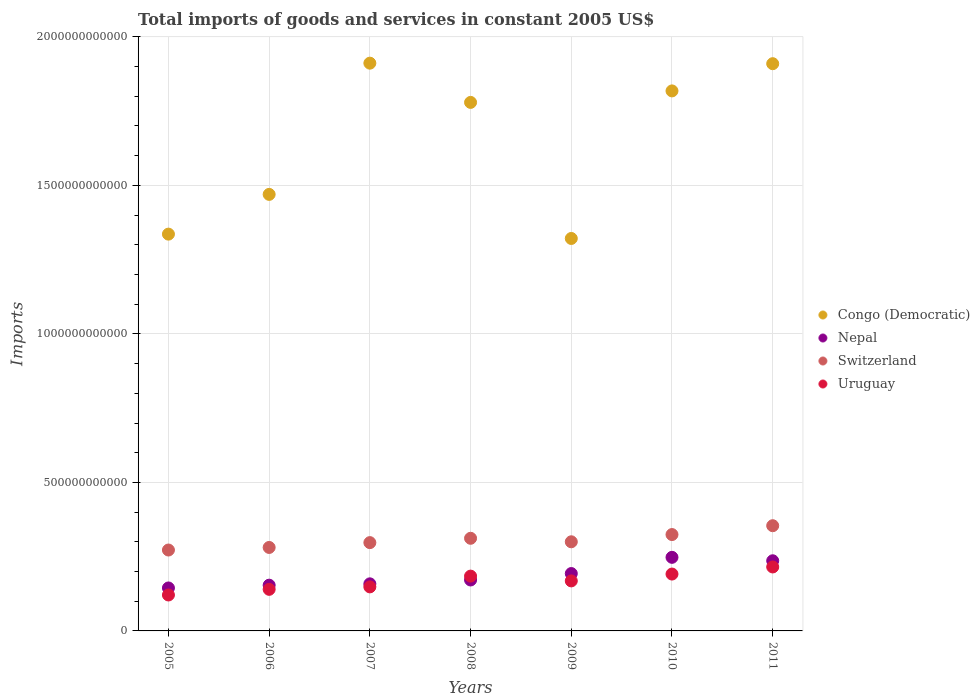How many different coloured dotlines are there?
Your answer should be very brief. 4. Is the number of dotlines equal to the number of legend labels?
Your answer should be compact. Yes. What is the total imports of goods and services in Switzerland in 2008?
Keep it short and to the point. 3.12e+11. Across all years, what is the maximum total imports of goods and services in Nepal?
Offer a terse response. 2.48e+11. Across all years, what is the minimum total imports of goods and services in Uruguay?
Give a very brief answer. 1.21e+11. In which year was the total imports of goods and services in Switzerland maximum?
Keep it short and to the point. 2011. In which year was the total imports of goods and services in Nepal minimum?
Offer a terse response. 2005. What is the total total imports of goods and services in Congo (Democratic) in the graph?
Give a very brief answer. 1.15e+13. What is the difference between the total imports of goods and services in Nepal in 2008 and that in 2010?
Your answer should be compact. -7.63e+1. What is the difference between the total imports of goods and services in Uruguay in 2011 and the total imports of goods and services in Switzerland in 2007?
Provide a short and direct response. -8.20e+1. What is the average total imports of goods and services in Uruguay per year?
Offer a very short reply. 1.67e+11. In the year 2011, what is the difference between the total imports of goods and services in Congo (Democratic) and total imports of goods and services in Uruguay?
Your response must be concise. 1.69e+12. What is the ratio of the total imports of goods and services in Nepal in 2010 to that in 2011?
Ensure brevity in your answer.  1.05. What is the difference between the highest and the second highest total imports of goods and services in Switzerland?
Offer a terse response. 2.98e+1. What is the difference between the highest and the lowest total imports of goods and services in Uruguay?
Your response must be concise. 9.43e+1. In how many years, is the total imports of goods and services in Uruguay greater than the average total imports of goods and services in Uruguay taken over all years?
Ensure brevity in your answer.  4. Is the sum of the total imports of goods and services in Congo (Democratic) in 2008 and 2011 greater than the maximum total imports of goods and services in Switzerland across all years?
Ensure brevity in your answer.  Yes. Is it the case that in every year, the sum of the total imports of goods and services in Switzerland and total imports of goods and services in Uruguay  is greater than the sum of total imports of goods and services in Nepal and total imports of goods and services in Congo (Democratic)?
Offer a very short reply. Yes. Is the total imports of goods and services in Congo (Democratic) strictly greater than the total imports of goods and services in Uruguay over the years?
Keep it short and to the point. Yes. Is the total imports of goods and services in Uruguay strictly less than the total imports of goods and services in Congo (Democratic) over the years?
Keep it short and to the point. Yes. How many dotlines are there?
Provide a succinct answer. 4. What is the difference between two consecutive major ticks on the Y-axis?
Ensure brevity in your answer.  5.00e+11. Are the values on the major ticks of Y-axis written in scientific E-notation?
Make the answer very short. No. Does the graph contain any zero values?
Your answer should be compact. No. How many legend labels are there?
Your answer should be compact. 4. What is the title of the graph?
Make the answer very short. Total imports of goods and services in constant 2005 US$. Does "Togo" appear as one of the legend labels in the graph?
Provide a succinct answer. No. What is the label or title of the X-axis?
Keep it short and to the point. Years. What is the label or title of the Y-axis?
Give a very brief answer. Imports. What is the Imports of Congo (Democratic) in 2005?
Offer a very short reply. 1.34e+12. What is the Imports in Nepal in 2005?
Offer a terse response. 1.45e+11. What is the Imports of Switzerland in 2005?
Your answer should be very brief. 2.72e+11. What is the Imports in Uruguay in 2005?
Keep it short and to the point. 1.21e+11. What is the Imports in Congo (Democratic) in 2006?
Offer a terse response. 1.47e+12. What is the Imports of Nepal in 2006?
Ensure brevity in your answer.  1.54e+11. What is the Imports in Switzerland in 2006?
Keep it short and to the point. 2.81e+11. What is the Imports in Uruguay in 2006?
Your answer should be very brief. 1.40e+11. What is the Imports in Congo (Democratic) in 2007?
Provide a succinct answer. 1.91e+12. What is the Imports of Nepal in 2007?
Your response must be concise. 1.59e+11. What is the Imports in Switzerland in 2007?
Offer a terse response. 2.97e+11. What is the Imports of Uruguay in 2007?
Your answer should be very brief. 1.48e+11. What is the Imports of Congo (Democratic) in 2008?
Ensure brevity in your answer.  1.78e+12. What is the Imports of Nepal in 2008?
Make the answer very short. 1.72e+11. What is the Imports in Switzerland in 2008?
Provide a succinct answer. 3.12e+11. What is the Imports in Uruguay in 2008?
Provide a short and direct response. 1.85e+11. What is the Imports of Congo (Democratic) in 2009?
Offer a very short reply. 1.32e+12. What is the Imports in Nepal in 2009?
Offer a very short reply. 1.93e+11. What is the Imports of Switzerland in 2009?
Keep it short and to the point. 3.00e+11. What is the Imports in Uruguay in 2009?
Offer a very short reply. 1.68e+11. What is the Imports in Congo (Democratic) in 2010?
Offer a very short reply. 1.82e+12. What is the Imports of Nepal in 2010?
Your answer should be compact. 2.48e+11. What is the Imports of Switzerland in 2010?
Offer a terse response. 3.24e+11. What is the Imports of Uruguay in 2010?
Offer a terse response. 1.91e+11. What is the Imports of Congo (Democratic) in 2011?
Offer a very short reply. 1.91e+12. What is the Imports of Nepal in 2011?
Keep it short and to the point. 2.36e+11. What is the Imports in Switzerland in 2011?
Your answer should be very brief. 3.54e+11. What is the Imports of Uruguay in 2011?
Make the answer very short. 2.15e+11. Across all years, what is the maximum Imports in Congo (Democratic)?
Ensure brevity in your answer.  1.91e+12. Across all years, what is the maximum Imports of Nepal?
Your answer should be very brief. 2.48e+11. Across all years, what is the maximum Imports in Switzerland?
Offer a very short reply. 3.54e+11. Across all years, what is the maximum Imports in Uruguay?
Offer a very short reply. 2.15e+11. Across all years, what is the minimum Imports in Congo (Democratic)?
Offer a very short reply. 1.32e+12. Across all years, what is the minimum Imports in Nepal?
Your response must be concise. 1.45e+11. Across all years, what is the minimum Imports of Switzerland?
Offer a terse response. 2.72e+11. Across all years, what is the minimum Imports of Uruguay?
Keep it short and to the point. 1.21e+11. What is the total Imports of Congo (Democratic) in the graph?
Make the answer very short. 1.15e+13. What is the total Imports in Nepal in the graph?
Offer a very short reply. 1.31e+12. What is the total Imports of Switzerland in the graph?
Ensure brevity in your answer.  2.14e+12. What is the total Imports in Uruguay in the graph?
Ensure brevity in your answer.  1.17e+12. What is the difference between the Imports of Congo (Democratic) in 2005 and that in 2006?
Ensure brevity in your answer.  -1.34e+11. What is the difference between the Imports in Nepal in 2005 and that in 2006?
Your answer should be compact. -9.34e+09. What is the difference between the Imports of Switzerland in 2005 and that in 2006?
Your answer should be very brief. -8.65e+09. What is the difference between the Imports of Uruguay in 2005 and that in 2006?
Provide a short and direct response. -1.90e+1. What is the difference between the Imports in Congo (Democratic) in 2005 and that in 2007?
Offer a terse response. -5.76e+11. What is the difference between the Imports in Nepal in 2005 and that in 2007?
Provide a short and direct response. -1.39e+1. What is the difference between the Imports of Switzerland in 2005 and that in 2007?
Ensure brevity in your answer.  -2.49e+1. What is the difference between the Imports of Uruguay in 2005 and that in 2007?
Provide a succinct answer. -2.73e+1. What is the difference between the Imports in Congo (Democratic) in 2005 and that in 2008?
Keep it short and to the point. -4.44e+11. What is the difference between the Imports in Nepal in 2005 and that in 2008?
Offer a terse response. -2.69e+1. What is the difference between the Imports in Switzerland in 2005 and that in 2008?
Your response must be concise. -3.95e+1. What is the difference between the Imports of Uruguay in 2005 and that in 2008?
Provide a short and direct response. -6.35e+1. What is the difference between the Imports of Congo (Democratic) in 2005 and that in 2009?
Offer a very short reply. 1.46e+1. What is the difference between the Imports in Nepal in 2005 and that in 2009?
Provide a short and direct response. -4.85e+1. What is the difference between the Imports in Switzerland in 2005 and that in 2009?
Give a very brief answer. -2.77e+1. What is the difference between the Imports of Uruguay in 2005 and that in 2009?
Make the answer very short. -4.74e+1. What is the difference between the Imports of Congo (Democratic) in 2005 and that in 2010?
Provide a short and direct response. -4.82e+11. What is the difference between the Imports of Nepal in 2005 and that in 2010?
Offer a terse response. -1.03e+11. What is the difference between the Imports of Switzerland in 2005 and that in 2010?
Offer a terse response. -5.21e+1. What is the difference between the Imports in Uruguay in 2005 and that in 2010?
Your response must be concise. -7.04e+1. What is the difference between the Imports of Congo (Democratic) in 2005 and that in 2011?
Provide a short and direct response. -5.74e+11. What is the difference between the Imports of Nepal in 2005 and that in 2011?
Keep it short and to the point. -9.15e+1. What is the difference between the Imports of Switzerland in 2005 and that in 2011?
Your answer should be compact. -8.19e+1. What is the difference between the Imports of Uruguay in 2005 and that in 2011?
Offer a terse response. -9.43e+1. What is the difference between the Imports of Congo (Democratic) in 2006 and that in 2007?
Give a very brief answer. -4.42e+11. What is the difference between the Imports of Nepal in 2006 and that in 2007?
Your answer should be compact. -4.54e+09. What is the difference between the Imports in Switzerland in 2006 and that in 2007?
Make the answer very short. -1.63e+1. What is the difference between the Imports of Uruguay in 2006 and that in 2007?
Your answer should be compact. -8.29e+09. What is the difference between the Imports of Congo (Democratic) in 2006 and that in 2008?
Offer a terse response. -3.10e+11. What is the difference between the Imports in Nepal in 2006 and that in 2008?
Keep it short and to the point. -1.75e+1. What is the difference between the Imports in Switzerland in 2006 and that in 2008?
Make the answer very short. -3.09e+1. What is the difference between the Imports in Uruguay in 2006 and that in 2008?
Make the answer very short. -4.45e+1. What is the difference between the Imports of Congo (Democratic) in 2006 and that in 2009?
Make the answer very short. 1.48e+11. What is the difference between the Imports in Nepal in 2006 and that in 2009?
Keep it short and to the point. -3.92e+1. What is the difference between the Imports in Switzerland in 2006 and that in 2009?
Make the answer very short. -1.91e+1. What is the difference between the Imports in Uruguay in 2006 and that in 2009?
Offer a terse response. -2.84e+1. What is the difference between the Imports of Congo (Democratic) in 2006 and that in 2010?
Your answer should be very brief. -3.48e+11. What is the difference between the Imports in Nepal in 2006 and that in 2010?
Your response must be concise. -9.38e+1. What is the difference between the Imports in Switzerland in 2006 and that in 2010?
Provide a succinct answer. -4.34e+1. What is the difference between the Imports of Uruguay in 2006 and that in 2010?
Give a very brief answer. -5.15e+1. What is the difference between the Imports in Congo (Democratic) in 2006 and that in 2011?
Provide a short and direct response. -4.40e+11. What is the difference between the Imports in Nepal in 2006 and that in 2011?
Offer a very short reply. -8.22e+1. What is the difference between the Imports in Switzerland in 2006 and that in 2011?
Provide a succinct answer. -7.32e+1. What is the difference between the Imports in Uruguay in 2006 and that in 2011?
Ensure brevity in your answer.  -7.53e+1. What is the difference between the Imports of Congo (Democratic) in 2007 and that in 2008?
Offer a terse response. 1.32e+11. What is the difference between the Imports of Nepal in 2007 and that in 2008?
Your answer should be very brief. -1.30e+1. What is the difference between the Imports of Switzerland in 2007 and that in 2008?
Your answer should be compact. -1.46e+1. What is the difference between the Imports in Uruguay in 2007 and that in 2008?
Your answer should be compact. -3.62e+1. What is the difference between the Imports in Congo (Democratic) in 2007 and that in 2009?
Your answer should be compact. 5.90e+11. What is the difference between the Imports in Nepal in 2007 and that in 2009?
Ensure brevity in your answer.  -3.47e+1. What is the difference between the Imports in Switzerland in 2007 and that in 2009?
Ensure brevity in your answer.  -2.79e+09. What is the difference between the Imports in Uruguay in 2007 and that in 2009?
Give a very brief answer. -2.01e+1. What is the difference between the Imports of Congo (Democratic) in 2007 and that in 2010?
Ensure brevity in your answer.  9.34e+1. What is the difference between the Imports of Nepal in 2007 and that in 2010?
Offer a terse response. -8.92e+1. What is the difference between the Imports of Switzerland in 2007 and that in 2010?
Give a very brief answer. -2.71e+1. What is the difference between the Imports in Uruguay in 2007 and that in 2010?
Give a very brief answer. -4.32e+1. What is the difference between the Imports of Congo (Democratic) in 2007 and that in 2011?
Your answer should be very brief. 1.77e+09. What is the difference between the Imports of Nepal in 2007 and that in 2011?
Offer a terse response. -7.76e+1. What is the difference between the Imports of Switzerland in 2007 and that in 2011?
Your response must be concise. -5.69e+1. What is the difference between the Imports of Uruguay in 2007 and that in 2011?
Provide a succinct answer. -6.70e+1. What is the difference between the Imports in Congo (Democratic) in 2008 and that in 2009?
Your answer should be very brief. 4.58e+11. What is the difference between the Imports of Nepal in 2008 and that in 2009?
Offer a very short reply. -2.17e+1. What is the difference between the Imports of Switzerland in 2008 and that in 2009?
Give a very brief answer. 1.18e+1. What is the difference between the Imports in Uruguay in 2008 and that in 2009?
Offer a very short reply. 1.61e+1. What is the difference between the Imports of Congo (Democratic) in 2008 and that in 2010?
Your answer should be compact. -3.87e+1. What is the difference between the Imports in Nepal in 2008 and that in 2010?
Make the answer very short. -7.63e+1. What is the difference between the Imports in Switzerland in 2008 and that in 2010?
Offer a very short reply. -1.25e+1. What is the difference between the Imports of Uruguay in 2008 and that in 2010?
Offer a very short reply. -6.94e+09. What is the difference between the Imports in Congo (Democratic) in 2008 and that in 2011?
Give a very brief answer. -1.30e+11. What is the difference between the Imports in Nepal in 2008 and that in 2011?
Provide a succinct answer. -6.46e+1. What is the difference between the Imports of Switzerland in 2008 and that in 2011?
Make the answer very short. -4.23e+1. What is the difference between the Imports in Uruguay in 2008 and that in 2011?
Keep it short and to the point. -3.08e+1. What is the difference between the Imports in Congo (Democratic) in 2009 and that in 2010?
Give a very brief answer. -4.97e+11. What is the difference between the Imports in Nepal in 2009 and that in 2010?
Your answer should be compact. -5.46e+1. What is the difference between the Imports in Switzerland in 2009 and that in 2010?
Give a very brief answer. -2.43e+1. What is the difference between the Imports in Uruguay in 2009 and that in 2010?
Provide a succinct answer. -2.30e+1. What is the difference between the Imports in Congo (Democratic) in 2009 and that in 2011?
Provide a short and direct response. -5.88e+11. What is the difference between the Imports in Nepal in 2009 and that in 2011?
Provide a short and direct response. -4.30e+1. What is the difference between the Imports in Switzerland in 2009 and that in 2011?
Your answer should be compact. -5.41e+1. What is the difference between the Imports of Uruguay in 2009 and that in 2011?
Provide a succinct answer. -4.69e+1. What is the difference between the Imports in Congo (Democratic) in 2010 and that in 2011?
Your answer should be compact. -9.16e+1. What is the difference between the Imports in Nepal in 2010 and that in 2011?
Offer a terse response. 1.16e+1. What is the difference between the Imports in Switzerland in 2010 and that in 2011?
Your answer should be compact. -2.98e+1. What is the difference between the Imports in Uruguay in 2010 and that in 2011?
Offer a terse response. -2.39e+1. What is the difference between the Imports of Congo (Democratic) in 2005 and the Imports of Nepal in 2006?
Your answer should be very brief. 1.18e+12. What is the difference between the Imports of Congo (Democratic) in 2005 and the Imports of Switzerland in 2006?
Your response must be concise. 1.05e+12. What is the difference between the Imports in Congo (Democratic) in 2005 and the Imports in Uruguay in 2006?
Make the answer very short. 1.20e+12. What is the difference between the Imports in Nepal in 2005 and the Imports in Switzerland in 2006?
Provide a succinct answer. -1.36e+11. What is the difference between the Imports of Nepal in 2005 and the Imports of Uruguay in 2006?
Offer a terse response. 4.66e+09. What is the difference between the Imports in Switzerland in 2005 and the Imports in Uruguay in 2006?
Offer a terse response. 1.32e+11. What is the difference between the Imports in Congo (Democratic) in 2005 and the Imports in Nepal in 2007?
Keep it short and to the point. 1.18e+12. What is the difference between the Imports in Congo (Democratic) in 2005 and the Imports in Switzerland in 2007?
Ensure brevity in your answer.  1.04e+12. What is the difference between the Imports of Congo (Democratic) in 2005 and the Imports of Uruguay in 2007?
Offer a terse response. 1.19e+12. What is the difference between the Imports in Nepal in 2005 and the Imports in Switzerland in 2007?
Provide a succinct answer. -1.53e+11. What is the difference between the Imports of Nepal in 2005 and the Imports of Uruguay in 2007?
Make the answer very short. -3.63e+09. What is the difference between the Imports of Switzerland in 2005 and the Imports of Uruguay in 2007?
Keep it short and to the point. 1.24e+11. What is the difference between the Imports in Congo (Democratic) in 2005 and the Imports in Nepal in 2008?
Provide a short and direct response. 1.16e+12. What is the difference between the Imports of Congo (Democratic) in 2005 and the Imports of Switzerland in 2008?
Keep it short and to the point. 1.02e+12. What is the difference between the Imports of Congo (Democratic) in 2005 and the Imports of Uruguay in 2008?
Provide a short and direct response. 1.15e+12. What is the difference between the Imports of Nepal in 2005 and the Imports of Switzerland in 2008?
Give a very brief answer. -1.67e+11. What is the difference between the Imports of Nepal in 2005 and the Imports of Uruguay in 2008?
Your answer should be compact. -3.99e+1. What is the difference between the Imports in Switzerland in 2005 and the Imports in Uruguay in 2008?
Ensure brevity in your answer.  8.79e+1. What is the difference between the Imports of Congo (Democratic) in 2005 and the Imports of Nepal in 2009?
Make the answer very short. 1.14e+12. What is the difference between the Imports in Congo (Democratic) in 2005 and the Imports in Switzerland in 2009?
Your answer should be compact. 1.04e+12. What is the difference between the Imports in Congo (Democratic) in 2005 and the Imports in Uruguay in 2009?
Offer a very short reply. 1.17e+12. What is the difference between the Imports of Nepal in 2005 and the Imports of Switzerland in 2009?
Your answer should be very brief. -1.55e+11. What is the difference between the Imports of Nepal in 2005 and the Imports of Uruguay in 2009?
Ensure brevity in your answer.  -2.38e+1. What is the difference between the Imports of Switzerland in 2005 and the Imports of Uruguay in 2009?
Offer a terse response. 1.04e+11. What is the difference between the Imports in Congo (Democratic) in 2005 and the Imports in Nepal in 2010?
Your response must be concise. 1.09e+12. What is the difference between the Imports of Congo (Democratic) in 2005 and the Imports of Switzerland in 2010?
Offer a terse response. 1.01e+12. What is the difference between the Imports of Congo (Democratic) in 2005 and the Imports of Uruguay in 2010?
Provide a succinct answer. 1.14e+12. What is the difference between the Imports of Nepal in 2005 and the Imports of Switzerland in 2010?
Ensure brevity in your answer.  -1.80e+11. What is the difference between the Imports in Nepal in 2005 and the Imports in Uruguay in 2010?
Provide a short and direct response. -4.68e+1. What is the difference between the Imports of Switzerland in 2005 and the Imports of Uruguay in 2010?
Ensure brevity in your answer.  8.09e+1. What is the difference between the Imports in Congo (Democratic) in 2005 and the Imports in Nepal in 2011?
Keep it short and to the point. 1.10e+12. What is the difference between the Imports of Congo (Democratic) in 2005 and the Imports of Switzerland in 2011?
Give a very brief answer. 9.82e+11. What is the difference between the Imports of Congo (Democratic) in 2005 and the Imports of Uruguay in 2011?
Provide a short and direct response. 1.12e+12. What is the difference between the Imports in Nepal in 2005 and the Imports in Switzerland in 2011?
Provide a succinct answer. -2.10e+11. What is the difference between the Imports in Nepal in 2005 and the Imports in Uruguay in 2011?
Give a very brief answer. -7.07e+1. What is the difference between the Imports of Switzerland in 2005 and the Imports of Uruguay in 2011?
Ensure brevity in your answer.  5.70e+1. What is the difference between the Imports in Congo (Democratic) in 2006 and the Imports in Nepal in 2007?
Your response must be concise. 1.31e+12. What is the difference between the Imports of Congo (Democratic) in 2006 and the Imports of Switzerland in 2007?
Give a very brief answer. 1.17e+12. What is the difference between the Imports of Congo (Democratic) in 2006 and the Imports of Uruguay in 2007?
Offer a terse response. 1.32e+12. What is the difference between the Imports in Nepal in 2006 and the Imports in Switzerland in 2007?
Ensure brevity in your answer.  -1.43e+11. What is the difference between the Imports of Nepal in 2006 and the Imports of Uruguay in 2007?
Make the answer very short. 5.71e+09. What is the difference between the Imports in Switzerland in 2006 and the Imports in Uruguay in 2007?
Your answer should be compact. 1.33e+11. What is the difference between the Imports of Congo (Democratic) in 2006 and the Imports of Nepal in 2008?
Ensure brevity in your answer.  1.30e+12. What is the difference between the Imports in Congo (Democratic) in 2006 and the Imports in Switzerland in 2008?
Your answer should be compact. 1.16e+12. What is the difference between the Imports in Congo (Democratic) in 2006 and the Imports in Uruguay in 2008?
Provide a succinct answer. 1.29e+12. What is the difference between the Imports of Nepal in 2006 and the Imports of Switzerland in 2008?
Make the answer very short. -1.58e+11. What is the difference between the Imports in Nepal in 2006 and the Imports in Uruguay in 2008?
Offer a terse response. -3.05e+1. What is the difference between the Imports of Switzerland in 2006 and the Imports of Uruguay in 2008?
Your answer should be compact. 9.65e+1. What is the difference between the Imports in Congo (Democratic) in 2006 and the Imports in Nepal in 2009?
Make the answer very short. 1.28e+12. What is the difference between the Imports in Congo (Democratic) in 2006 and the Imports in Switzerland in 2009?
Provide a short and direct response. 1.17e+12. What is the difference between the Imports of Congo (Democratic) in 2006 and the Imports of Uruguay in 2009?
Offer a very short reply. 1.30e+12. What is the difference between the Imports in Nepal in 2006 and the Imports in Switzerland in 2009?
Offer a very short reply. -1.46e+11. What is the difference between the Imports of Nepal in 2006 and the Imports of Uruguay in 2009?
Offer a very short reply. -1.44e+1. What is the difference between the Imports in Switzerland in 2006 and the Imports in Uruguay in 2009?
Your answer should be compact. 1.13e+11. What is the difference between the Imports of Congo (Democratic) in 2006 and the Imports of Nepal in 2010?
Keep it short and to the point. 1.22e+12. What is the difference between the Imports of Congo (Democratic) in 2006 and the Imports of Switzerland in 2010?
Your answer should be compact. 1.15e+12. What is the difference between the Imports of Congo (Democratic) in 2006 and the Imports of Uruguay in 2010?
Provide a succinct answer. 1.28e+12. What is the difference between the Imports of Nepal in 2006 and the Imports of Switzerland in 2010?
Provide a short and direct response. -1.70e+11. What is the difference between the Imports of Nepal in 2006 and the Imports of Uruguay in 2010?
Offer a very short reply. -3.75e+1. What is the difference between the Imports of Switzerland in 2006 and the Imports of Uruguay in 2010?
Make the answer very short. 8.96e+1. What is the difference between the Imports of Congo (Democratic) in 2006 and the Imports of Nepal in 2011?
Offer a very short reply. 1.23e+12. What is the difference between the Imports in Congo (Democratic) in 2006 and the Imports in Switzerland in 2011?
Make the answer very short. 1.12e+12. What is the difference between the Imports of Congo (Democratic) in 2006 and the Imports of Uruguay in 2011?
Provide a short and direct response. 1.25e+12. What is the difference between the Imports in Nepal in 2006 and the Imports in Switzerland in 2011?
Ensure brevity in your answer.  -2.00e+11. What is the difference between the Imports in Nepal in 2006 and the Imports in Uruguay in 2011?
Give a very brief answer. -6.13e+1. What is the difference between the Imports of Switzerland in 2006 and the Imports of Uruguay in 2011?
Offer a terse response. 6.57e+1. What is the difference between the Imports in Congo (Democratic) in 2007 and the Imports in Nepal in 2008?
Offer a terse response. 1.74e+12. What is the difference between the Imports in Congo (Democratic) in 2007 and the Imports in Switzerland in 2008?
Provide a succinct answer. 1.60e+12. What is the difference between the Imports in Congo (Democratic) in 2007 and the Imports in Uruguay in 2008?
Provide a short and direct response. 1.73e+12. What is the difference between the Imports of Nepal in 2007 and the Imports of Switzerland in 2008?
Your answer should be very brief. -1.53e+11. What is the difference between the Imports of Nepal in 2007 and the Imports of Uruguay in 2008?
Your answer should be very brief. -2.60e+1. What is the difference between the Imports of Switzerland in 2007 and the Imports of Uruguay in 2008?
Keep it short and to the point. 1.13e+11. What is the difference between the Imports in Congo (Democratic) in 2007 and the Imports in Nepal in 2009?
Ensure brevity in your answer.  1.72e+12. What is the difference between the Imports in Congo (Democratic) in 2007 and the Imports in Switzerland in 2009?
Keep it short and to the point. 1.61e+12. What is the difference between the Imports in Congo (Democratic) in 2007 and the Imports in Uruguay in 2009?
Provide a succinct answer. 1.74e+12. What is the difference between the Imports of Nepal in 2007 and the Imports of Switzerland in 2009?
Give a very brief answer. -1.42e+11. What is the difference between the Imports of Nepal in 2007 and the Imports of Uruguay in 2009?
Give a very brief answer. -9.88e+09. What is the difference between the Imports of Switzerland in 2007 and the Imports of Uruguay in 2009?
Ensure brevity in your answer.  1.29e+11. What is the difference between the Imports of Congo (Democratic) in 2007 and the Imports of Nepal in 2010?
Your answer should be very brief. 1.66e+12. What is the difference between the Imports in Congo (Democratic) in 2007 and the Imports in Switzerland in 2010?
Keep it short and to the point. 1.59e+12. What is the difference between the Imports in Congo (Democratic) in 2007 and the Imports in Uruguay in 2010?
Your response must be concise. 1.72e+12. What is the difference between the Imports in Nepal in 2007 and the Imports in Switzerland in 2010?
Your answer should be compact. -1.66e+11. What is the difference between the Imports of Nepal in 2007 and the Imports of Uruguay in 2010?
Your answer should be very brief. -3.29e+1. What is the difference between the Imports of Switzerland in 2007 and the Imports of Uruguay in 2010?
Offer a terse response. 1.06e+11. What is the difference between the Imports of Congo (Democratic) in 2007 and the Imports of Nepal in 2011?
Provide a short and direct response. 1.68e+12. What is the difference between the Imports of Congo (Democratic) in 2007 and the Imports of Switzerland in 2011?
Provide a succinct answer. 1.56e+12. What is the difference between the Imports in Congo (Democratic) in 2007 and the Imports in Uruguay in 2011?
Your answer should be compact. 1.70e+12. What is the difference between the Imports of Nepal in 2007 and the Imports of Switzerland in 2011?
Keep it short and to the point. -1.96e+11. What is the difference between the Imports of Nepal in 2007 and the Imports of Uruguay in 2011?
Make the answer very short. -5.68e+1. What is the difference between the Imports of Switzerland in 2007 and the Imports of Uruguay in 2011?
Your response must be concise. 8.20e+1. What is the difference between the Imports of Congo (Democratic) in 2008 and the Imports of Nepal in 2009?
Provide a succinct answer. 1.59e+12. What is the difference between the Imports in Congo (Democratic) in 2008 and the Imports in Switzerland in 2009?
Offer a terse response. 1.48e+12. What is the difference between the Imports in Congo (Democratic) in 2008 and the Imports in Uruguay in 2009?
Ensure brevity in your answer.  1.61e+12. What is the difference between the Imports in Nepal in 2008 and the Imports in Switzerland in 2009?
Your response must be concise. -1.29e+11. What is the difference between the Imports of Nepal in 2008 and the Imports of Uruguay in 2009?
Ensure brevity in your answer.  3.11e+09. What is the difference between the Imports of Switzerland in 2008 and the Imports of Uruguay in 2009?
Your answer should be compact. 1.43e+11. What is the difference between the Imports in Congo (Democratic) in 2008 and the Imports in Nepal in 2010?
Your response must be concise. 1.53e+12. What is the difference between the Imports in Congo (Democratic) in 2008 and the Imports in Switzerland in 2010?
Make the answer very short. 1.45e+12. What is the difference between the Imports of Congo (Democratic) in 2008 and the Imports of Uruguay in 2010?
Offer a very short reply. 1.59e+12. What is the difference between the Imports of Nepal in 2008 and the Imports of Switzerland in 2010?
Your answer should be very brief. -1.53e+11. What is the difference between the Imports of Nepal in 2008 and the Imports of Uruguay in 2010?
Your answer should be compact. -1.99e+1. What is the difference between the Imports of Switzerland in 2008 and the Imports of Uruguay in 2010?
Offer a very short reply. 1.20e+11. What is the difference between the Imports of Congo (Democratic) in 2008 and the Imports of Nepal in 2011?
Keep it short and to the point. 1.54e+12. What is the difference between the Imports of Congo (Democratic) in 2008 and the Imports of Switzerland in 2011?
Provide a short and direct response. 1.43e+12. What is the difference between the Imports in Congo (Democratic) in 2008 and the Imports in Uruguay in 2011?
Offer a very short reply. 1.56e+12. What is the difference between the Imports in Nepal in 2008 and the Imports in Switzerland in 2011?
Your answer should be very brief. -1.83e+11. What is the difference between the Imports in Nepal in 2008 and the Imports in Uruguay in 2011?
Make the answer very short. -4.38e+1. What is the difference between the Imports in Switzerland in 2008 and the Imports in Uruguay in 2011?
Make the answer very short. 9.66e+1. What is the difference between the Imports of Congo (Democratic) in 2009 and the Imports of Nepal in 2010?
Your answer should be very brief. 1.07e+12. What is the difference between the Imports of Congo (Democratic) in 2009 and the Imports of Switzerland in 2010?
Keep it short and to the point. 9.97e+11. What is the difference between the Imports in Congo (Democratic) in 2009 and the Imports in Uruguay in 2010?
Offer a very short reply. 1.13e+12. What is the difference between the Imports of Nepal in 2009 and the Imports of Switzerland in 2010?
Ensure brevity in your answer.  -1.31e+11. What is the difference between the Imports of Nepal in 2009 and the Imports of Uruguay in 2010?
Provide a succinct answer. 1.73e+09. What is the difference between the Imports of Switzerland in 2009 and the Imports of Uruguay in 2010?
Provide a succinct answer. 1.09e+11. What is the difference between the Imports in Congo (Democratic) in 2009 and the Imports in Nepal in 2011?
Offer a terse response. 1.09e+12. What is the difference between the Imports of Congo (Democratic) in 2009 and the Imports of Switzerland in 2011?
Offer a terse response. 9.67e+11. What is the difference between the Imports in Congo (Democratic) in 2009 and the Imports in Uruguay in 2011?
Your answer should be compact. 1.11e+12. What is the difference between the Imports of Nepal in 2009 and the Imports of Switzerland in 2011?
Ensure brevity in your answer.  -1.61e+11. What is the difference between the Imports of Nepal in 2009 and the Imports of Uruguay in 2011?
Your answer should be very brief. -2.21e+1. What is the difference between the Imports in Switzerland in 2009 and the Imports in Uruguay in 2011?
Provide a succinct answer. 8.48e+1. What is the difference between the Imports of Congo (Democratic) in 2010 and the Imports of Nepal in 2011?
Your answer should be compact. 1.58e+12. What is the difference between the Imports in Congo (Democratic) in 2010 and the Imports in Switzerland in 2011?
Offer a terse response. 1.46e+12. What is the difference between the Imports of Congo (Democratic) in 2010 and the Imports of Uruguay in 2011?
Your answer should be very brief. 1.60e+12. What is the difference between the Imports in Nepal in 2010 and the Imports in Switzerland in 2011?
Your answer should be compact. -1.06e+11. What is the difference between the Imports in Nepal in 2010 and the Imports in Uruguay in 2011?
Your answer should be very brief. 3.24e+1. What is the difference between the Imports in Switzerland in 2010 and the Imports in Uruguay in 2011?
Ensure brevity in your answer.  1.09e+11. What is the average Imports of Congo (Democratic) per year?
Provide a short and direct response. 1.65e+12. What is the average Imports in Nepal per year?
Keep it short and to the point. 1.87e+11. What is the average Imports in Switzerland per year?
Your answer should be very brief. 3.06e+11. What is the average Imports in Uruguay per year?
Your answer should be very brief. 1.67e+11. In the year 2005, what is the difference between the Imports of Congo (Democratic) and Imports of Nepal?
Give a very brief answer. 1.19e+12. In the year 2005, what is the difference between the Imports of Congo (Democratic) and Imports of Switzerland?
Provide a succinct answer. 1.06e+12. In the year 2005, what is the difference between the Imports of Congo (Democratic) and Imports of Uruguay?
Offer a terse response. 1.21e+12. In the year 2005, what is the difference between the Imports of Nepal and Imports of Switzerland?
Your answer should be compact. -1.28e+11. In the year 2005, what is the difference between the Imports of Nepal and Imports of Uruguay?
Provide a short and direct response. 2.36e+1. In the year 2005, what is the difference between the Imports of Switzerland and Imports of Uruguay?
Ensure brevity in your answer.  1.51e+11. In the year 2006, what is the difference between the Imports in Congo (Democratic) and Imports in Nepal?
Your response must be concise. 1.32e+12. In the year 2006, what is the difference between the Imports in Congo (Democratic) and Imports in Switzerland?
Offer a terse response. 1.19e+12. In the year 2006, what is the difference between the Imports of Congo (Democratic) and Imports of Uruguay?
Offer a terse response. 1.33e+12. In the year 2006, what is the difference between the Imports in Nepal and Imports in Switzerland?
Provide a short and direct response. -1.27e+11. In the year 2006, what is the difference between the Imports in Nepal and Imports in Uruguay?
Your answer should be very brief. 1.40e+1. In the year 2006, what is the difference between the Imports of Switzerland and Imports of Uruguay?
Give a very brief answer. 1.41e+11. In the year 2007, what is the difference between the Imports of Congo (Democratic) and Imports of Nepal?
Your answer should be compact. 1.75e+12. In the year 2007, what is the difference between the Imports in Congo (Democratic) and Imports in Switzerland?
Your response must be concise. 1.61e+12. In the year 2007, what is the difference between the Imports of Congo (Democratic) and Imports of Uruguay?
Make the answer very short. 1.76e+12. In the year 2007, what is the difference between the Imports of Nepal and Imports of Switzerland?
Make the answer very short. -1.39e+11. In the year 2007, what is the difference between the Imports in Nepal and Imports in Uruguay?
Offer a terse response. 1.02e+1. In the year 2007, what is the difference between the Imports of Switzerland and Imports of Uruguay?
Give a very brief answer. 1.49e+11. In the year 2008, what is the difference between the Imports of Congo (Democratic) and Imports of Nepal?
Offer a very short reply. 1.61e+12. In the year 2008, what is the difference between the Imports of Congo (Democratic) and Imports of Switzerland?
Provide a succinct answer. 1.47e+12. In the year 2008, what is the difference between the Imports in Congo (Democratic) and Imports in Uruguay?
Provide a succinct answer. 1.59e+12. In the year 2008, what is the difference between the Imports in Nepal and Imports in Switzerland?
Your response must be concise. -1.40e+11. In the year 2008, what is the difference between the Imports in Nepal and Imports in Uruguay?
Your response must be concise. -1.30e+1. In the year 2008, what is the difference between the Imports of Switzerland and Imports of Uruguay?
Provide a succinct answer. 1.27e+11. In the year 2009, what is the difference between the Imports in Congo (Democratic) and Imports in Nepal?
Offer a terse response. 1.13e+12. In the year 2009, what is the difference between the Imports of Congo (Democratic) and Imports of Switzerland?
Your answer should be compact. 1.02e+12. In the year 2009, what is the difference between the Imports in Congo (Democratic) and Imports in Uruguay?
Provide a short and direct response. 1.15e+12. In the year 2009, what is the difference between the Imports of Nepal and Imports of Switzerland?
Provide a short and direct response. -1.07e+11. In the year 2009, what is the difference between the Imports of Nepal and Imports of Uruguay?
Give a very brief answer. 2.48e+1. In the year 2009, what is the difference between the Imports in Switzerland and Imports in Uruguay?
Ensure brevity in your answer.  1.32e+11. In the year 2010, what is the difference between the Imports in Congo (Democratic) and Imports in Nepal?
Make the answer very short. 1.57e+12. In the year 2010, what is the difference between the Imports in Congo (Democratic) and Imports in Switzerland?
Provide a short and direct response. 1.49e+12. In the year 2010, what is the difference between the Imports in Congo (Democratic) and Imports in Uruguay?
Your response must be concise. 1.63e+12. In the year 2010, what is the difference between the Imports of Nepal and Imports of Switzerland?
Your answer should be very brief. -7.67e+1. In the year 2010, what is the difference between the Imports of Nepal and Imports of Uruguay?
Offer a very short reply. 5.63e+1. In the year 2010, what is the difference between the Imports of Switzerland and Imports of Uruguay?
Your answer should be compact. 1.33e+11. In the year 2011, what is the difference between the Imports of Congo (Democratic) and Imports of Nepal?
Make the answer very short. 1.67e+12. In the year 2011, what is the difference between the Imports in Congo (Democratic) and Imports in Switzerland?
Ensure brevity in your answer.  1.56e+12. In the year 2011, what is the difference between the Imports of Congo (Democratic) and Imports of Uruguay?
Keep it short and to the point. 1.69e+12. In the year 2011, what is the difference between the Imports in Nepal and Imports in Switzerland?
Provide a succinct answer. -1.18e+11. In the year 2011, what is the difference between the Imports in Nepal and Imports in Uruguay?
Ensure brevity in your answer.  2.08e+1. In the year 2011, what is the difference between the Imports in Switzerland and Imports in Uruguay?
Offer a terse response. 1.39e+11. What is the ratio of the Imports in Congo (Democratic) in 2005 to that in 2006?
Provide a short and direct response. 0.91. What is the ratio of the Imports in Nepal in 2005 to that in 2006?
Offer a terse response. 0.94. What is the ratio of the Imports in Switzerland in 2005 to that in 2006?
Offer a terse response. 0.97. What is the ratio of the Imports in Uruguay in 2005 to that in 2006?
Provide a short and direct response. 0.86. What is the ratio of the Imports of Congo (Democratic) in 2005 to that in 2007?
Your answer should be compact. 0.7. What is the ratio of the Imports in Nepal in 2005 to that in 2007?
Your answer should be very brief. 0.91. What is the ratio of the Imports in Switzerland in 2005 to that in 2007?
Keep it short and to the point. 0.92. What is the ratio of the Imports of Uruguay in 2005 to that in 2007?
Ensure brevity in your answer.  0.82. What is the ratio of the Imports in Congo (Democratic) in 2005 to that in 2008?
Provide a short and direct response. 0.75. What is the ratio of the Imports of Nepal in 2005 to that in 2008?
Keep it short and to the point. 0.84. What is the ratio of the Imports in Switzerland in 2005 to that in 2008?
Your response must be concise. 0.87. What is the ratio of the Imports in Uruguay in 2005 to that in 2008?
Offer a terse response. 0.66. What is the ratio of the Imports of Congo (Democratic) in 2005 to that in 2009?
Offer a very short reply. 1.01. What is the ratio of the Imports of Nepal in 2005 to that in 2009?
Make the answer very short. 0.75. What is the ratio of the Imports of Switzerland in 2005 to that in 2009?
Give a very brief answer. 0.91. What is the ratio of the Imports of Uruguay in 2005 to that in 2009?
Offer a very short reply. 0.72. What is the ratio of the Imports in Congo (Democratic) in 2005 to that in 2010?
Give a very brief answer. 0.73. What is the ratio of the Imports in Nepal in 2005 to that in 2010?
Give a very brief answer. 0.58. What is the ratio of the Imports of Switzerland in 2005 to that in 2010?
Keep it short and to the point. 0.84. What is the ratio of the Imports of Uruguay in 2005 to that in 2010?
Your answer should be compact. 0.63. What is the ratio of the Imports of Congo (Democratic) in 2005 to that in 2011?
Provide a short and direct response. 0.7. What is the ratio of the Imports in Nepal in 2005 to that in 2011?
Offer a terse response. 0.61. What is the ratio of the Imports of Switzerland in 2005 to that in 2011?
Provide a succinct answer. 0.77. What is the ratio of the Imports of Uruguay in 2005 to that in 2011?
Offer a very short reply. 0.56. What is the ratio of the Imports in Congo (Democratic) in 2006 to that in 2007?
Provide a succinct answer. 0.77. What is the ratio of the Imports of Nepal in 2006 to that in 2007?
Give a very brief answer. 0.97. What is the ratio of the Imports of Switzerland in 2006 to that in 2007?
Your answer should be compact. 0.95. What is the ratio of the Imports of Uruguay in 2006 to that in 2007?
Provide a short and direct response. 0.94. What is the ratio of the Imports of Congo (Democratic) in 2006 to that in 2008?
Give a very brief answer. 0.83. What is the ratio of the Imports in Nepal in 2006 to that in 2008?
Make the answer very short. 0.9. What is the ratio of the Imports of Switzerland in 2006 to that in 2008?
Provide a succinct answer. 0.9. What is the ratio of the Imports in Uruguay in 2006 to that in 2008?
Make the answer very short. 0.76. What is the ratio of the Imports of Congo (Democratic) in 2006 to that in 2009?
Your response must be concise. 1.11. What is the ratio of the Imports in Nepal in 2006 to that in 2009?
Your answer should be compact. 0.8. What is the ratio of the Imports of Switzerland in 2006 to that in 2009?
Ensure brevity in your answer.  0.94. What is the ratio of the Imports of Uruguay in 2006 to that in 2009?
Your answer should be very brief. 0.83. What is the ratio of the Imports of Congo (Democratic) in 2006 to that in 2010?
Ensure brevity in your answer.  0.81. What is the ratio of the Imports of Nepal in 2006 to that in 2010?
Keep it short and to the point. 0.62. What is the ratio of the Imports in Switzerland in 2006 to that in 2010?
Your answer should be very brief. 0.87. What is the ratio of the Imports of Uruguay in 2006 to that in 2010?
Provide a short and direct response. 0.73. What is the ratio of the Imports of Congo (Democratic) in 2006 to that in 2011?
Provide a short and direct response. 0.77. What is the ratio of the Imports of Nepal in 2006 to that in 2011?
Offer a very short reply. 0.65. What is the ratio of the Imports in Switzerland in 2006 to that in 2011?
Offer a terse response. 0.79. What is the ratio of the Imports in Uruguay in 2006 to that in 2011?
Provide a succinct answer. 0.65. What is the ratio of the Imports in Congo (Democratic) in 2007 to that in 2008?
Make the answer very short. 1.07. What is the ratio of the Imports in Nepal in 2007 to that in 2008?
Ensure brevity in your answer.  0.92. What is the ratio of the Imports of Switzerland in 2007 to that in 2008?
Give a very brief answer. 0.95. What is the ratio of the Imports in Uruguay in 2007 to that in 2008?
Offer a very short reply. 0.8. What is the ratio of the Imports of Congo (Democratic) in 2007 to that in 2009?
Offer a terse response. 1.45. What is the ratio of the Imports of Nepal in 2007 to that in 2009?
Make the answer very short. 0.82. What is the ratio of the Imports of Uruguay in 2007 to that in 2009?
Give a very brief answer. 0.88. What is the ratio of the Imports of Congo (Democratic) in 2007 to that in 2010?
Provide a succinct answer. 1.05. What is the ratio of the Imports of Nepal in 2007 to that in 2010?
Your answer should be very brief. 0.64. What is the ratio of the Imports of Switzerland in 2007 to that in 2010?
Offer a terse response. 0.92. What is the ratio of the Imports in Uruguay in 2007 to that in 2010?
Offer a terse response. 0.77. What is the ratio of the Imports of Congo (Democratic) in 2007 to that in 2011?
Keep it short and to the point. 1. What is the ratio of the Imports in Nepal in 2007 to that in 2011?
Provide a succinct answer. 0.67. What is the ratio of the Imports in Switzerland in 2007 to that in 2011?
Make the answer very short. 0.84. What is the ratio of the Imports of Uruguay in 2007 to that in 2011?
Provide a succinct answer. 0.69. What is the ratio of the Imports of Congo (Democratic) in 2008 to that in 2009?
Your answer should be very brief. 1.35. What is the ratio of the Imports in Nepal in 2008 to that in 2009?
Make the answer very short. 0.89. What is the ratio of the Imports in Switzerland in 2008 to that in 2009?
Your answer should be compact. 1.04. What is the ratio of the Imports of Uruguay in 2008 to that in 2009?
Offer a very short reply. 1.1. What is the ratio of the Imports in Congo (Democratic) in 2008 to that in 2010?
Give a very brief answer. 0.98. What is the ratio of the Imports of Nepal in 2008 to that in 2010?
Make the answer very short. 0.69. What is the ratio of the Imports in Switzerland in 2008 to that in 2010?
Provide a succinct answer. 0.96. What is the ratio of the Imports in Uruguay in 2008 to that in 2010?
Your response must be concise. 0.96. What is the ratio of the Imports of Congo (Democratic) in 2008 to that in 2011?
Ensure brevity in your answer.  0.93. What is the ratio of the Imports in Nepal in 2008 to that in 2011?
Give a very brief answer. 0.73. What is the ratio of the Imports in Switzerland in 2008 to that in 2011?
Your answer should be very brief. 0.88. What is the ratio of the Imports of Uruguay in 2008 to that in 2011?
Offer a terse response. 0.86. What is the ratio of the Imports in Congo (Democratic) in 2009 to that in 2010?
Make the answer very short. 0.73. What is the ratio of the Imports in Nepal in 2009 to that in 2010?
Your answer should be very brief. 0.78. What is the ratio of the Imports of Switzerland in 2009 to that in 2010?
Your response must be concise. 0.93. What is the ratio of the Imports in Uruguay in 2009 to that in 2010?
Keep it short and to the point. 0.88. What is the ratio of the Imports in Congo (Democratic) in 2009 to that in 2011?
Provide a succinct answer. 0.69. What is the ratio of the Imports of Nepal in 2009 to that in 2011?
Keep it short and to the point. 0.82. What is the ratio of the Imports of Switzerland in 2009 to that in 2011?
Offer a terse response. 0.85. What is the ratio of the Imports of Uruguay in 2009 to that in 2011?
Ensure brevity in your answer.  0.78. What is the ratio of the Imports of Congo (Democratic) in 2010 to that in 2011?
Keep it short and to the point. 0.95. What is the ratio of the Imports in Nepal in 2010 to that in 2011?
Provide a short and direct response. 1.05. What is the ratio of the Imports of Switzerland in 2010 to that in 2011?
Offer a terse response. 0.92. What is the ratio of the Imports in Uruguay in 2010 to that in 2011?
Give a very brief answer. 0.89. What is the difference between the highest and the second highest Imports of Congo (Democratic)?
Keep it short and to the point. 1.77e+09. What is the difference between the highest and the second highest Imports of Nepal?
Offer a very short reply. 1.16e+1. What is the difference between the highest and the second highest Imports of Switzerland?
Provide a short and direct response. 2.98e+1. What is the difference between the highest and the second highest Imports in Uruguay?
Make the answer very short. 2.39e+1. What is the difference between the highest and the lowest Imports of Congo (Democratic)?
Ensure brevity in your answer.  5.90e+11. What is the difference between the highest and the lowest Imports of Nepal?
Your answer should be compact. 1.03e+11. What is the difference between the highest and the lowest Imports of Switzerland?
Ensure brevity in your answer.  8.19e+1. What is the difference between the highest and the lowest Imports in Uruguay?
Offer a terse response. 9.43e+1. 